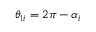<formula> <loc_0><loc_0><loc_500><loc_500>\theta _ { 1 i } = 2 \pi - \alpha _ { i }</formula> 